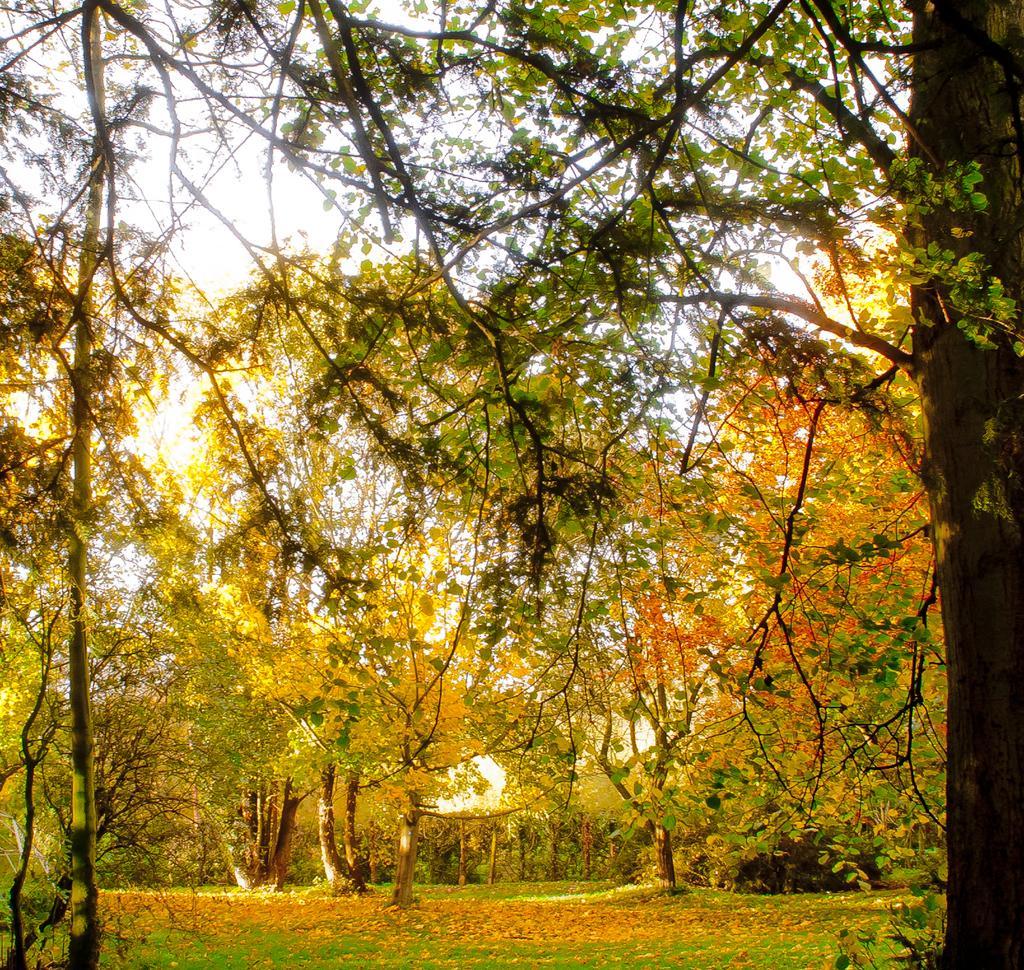Describe this image in one or two sentences. In the image we can see some trees. 